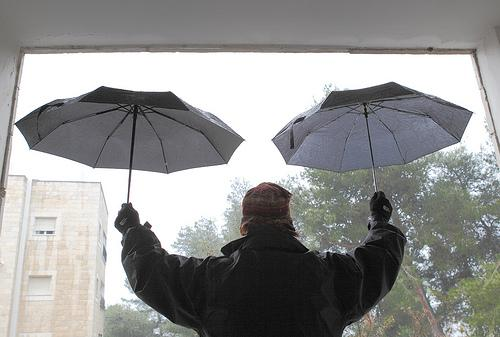Describe the pose of the person and what is hanging from the umbrellas. The person is holding out two black umbrellas, one in each hand, with black straps hanging from them. Can you identify any visible logos on the person's attire? Yes, there are white 'The North Face' logos on both of the man's black gloves. In which corner of the image can you find a tree? A tree with green leaves and a brown trunk can be found at the top-right corner of the image. List the colors of the different objects in the image. Black umbrellas, poles, gloves, jacket, and strap; red and brown beanie; white north face logos; peach building; green leaves; brown trunk; overcast sky. Indicate which hand the person is wearing a certain glove. A black glove with the north face logo is worn on the person's right hand. Describe the person in the image, and what kind of hat they are wearing. The person is a man wearing a jacket, gloves, and a red and brown beanie with a pattern. Explain the scene and mention how's the weather like. A man wearing a hat, black jacket and gloves is holding two black umbrellas in front of a building with a partially opened window. The weather is overcast. What kind of objects can be spotted in the background of the image? A peach-colored building with a partially opened window, trees with green leaves and brown trunk, and an overcast sky are visible in the background. 